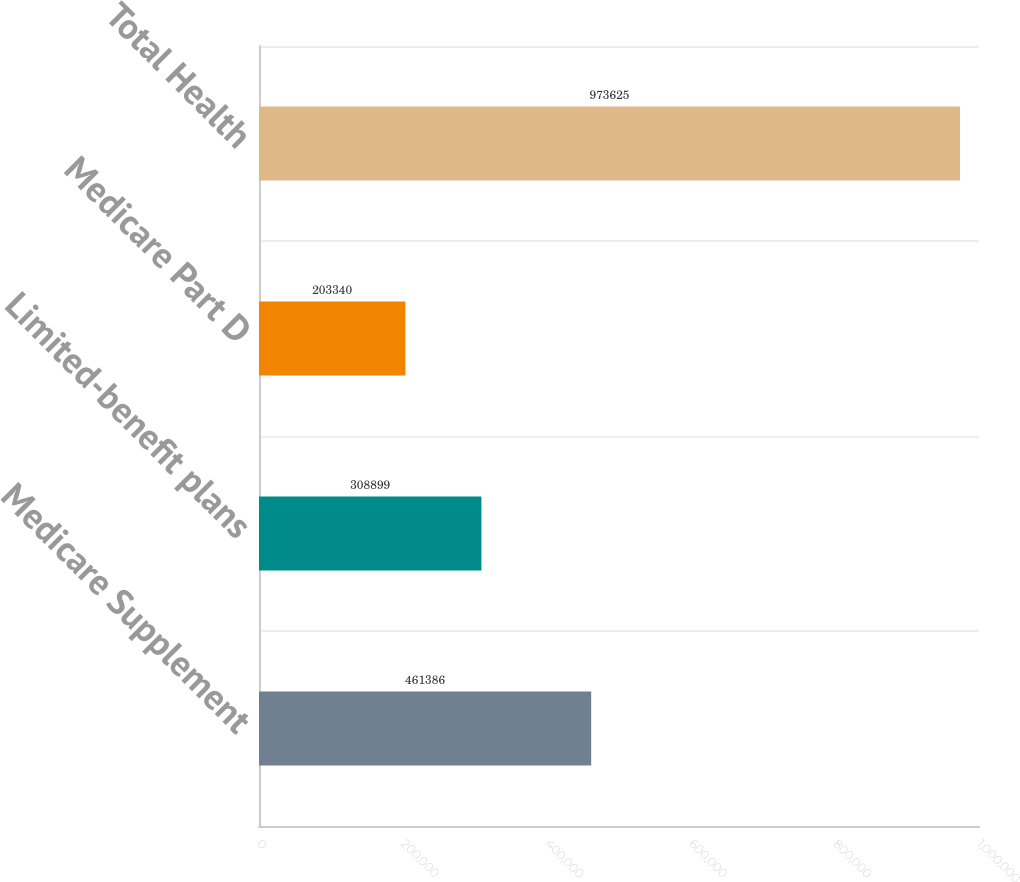<chart> <loc_0><loc_0><loc_500><loc_500><bar_chart><fcel>Medicare Supplement<fcel>Limited-benefit plans<fcel>Medicare Part D<fcel>Total Health<nl><fcel>461386<fcel>308899<fcel>203340<fcel>973625<nl></chart> 